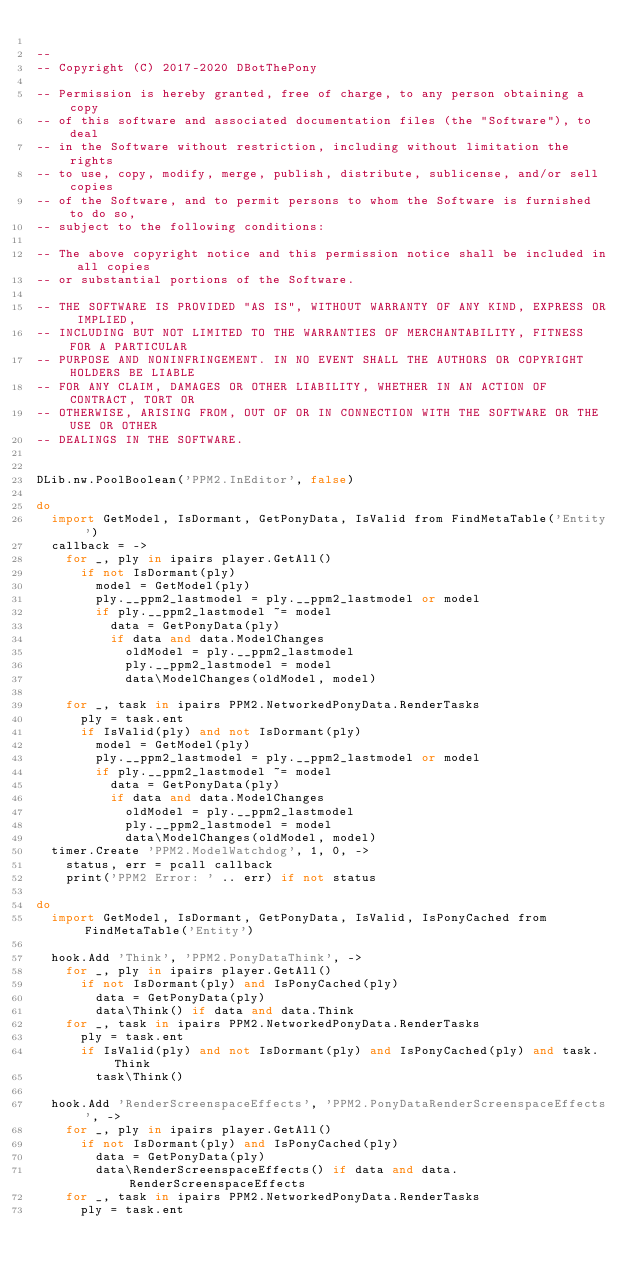<code> <loc_0><loc_0><loc_500><loc_500><_MoonScript_>
--
-- Copyright (C) 2017-2020 DBotThePony

-- Permission is hereby granted, free of charge, to any person obtaining a copy
-- of this software and associated documentation files (the "Software"), to deal
-- in the Software without restriction, including without limitation the rights
-- to use, copy, modify, merge, publish, distribute, sublicense, and/or sell copies
-- of the Software, and to permit persons to whom the Software is furnished to do so,
-- subject to the following conditions:

-- The above copyright notice and this permission notice shall be included in all copies
-- or substantial portions of the Software.

-- THE SOFTWARE IS PROVIDED "AS IS", WITHOUT WARRANTY OF ANY KIND, EXPRESS OR IMPLIED,
-- INCLUDING BUT NOT LIMITED TO THE WARRANTIES OF MERCHANTABILITY, FITNESS FOR A PARTICULAR
-- PURPOSE AND NONINFRINGEMENT. IN NO EVENT SHALL THE AUTHORS OR COPYRIGHT HOLDERS BE LIABLE
-- FOR ANY CLAIM, DAMAGES OR OTHER LIABILITY, WHETHER IN AN ACTION OF CONTRACT, TORT OR
-- OTHERWISE, ARISING FROM, OUT OF OR IN CONNECTION WITH THE SOFTWARE OR THE USE OR OTHER
-- DEALINGS IN THE SOFTWARE.


DLib.nw.PoolBoolean('PPM2.InEditor', false)

do
	import GetModel, IsDormant, GetPonyData, IsValid from FindMetaTable('Entity')
	callback = ->
		for _, ply in ipairs player.GetAll()
			if not IsDormant(ply)
				model = GetModel(ply)
				ply.__ppm2_lastmodel = ply.__ppm2_lastmodel or model
				if ply.__ppm2_lastmodel ~= model
					data = GetPonyData(ply)
					if data and data.ModelChanges
						oldModel = ply.__ppm2_lastmodel
						ply.__ppm2_lastmodel = model
						data\ModelChanges(oldModel, model)

		for _, task in ipairs PPM2.NetworkedPonyData.RenderTasks
			ply = task.ent
			if IsValid(ply) and not IsDormant(ply)
				model = GetModel(ply)
				ply.__ppm2_lastmodel = ply.__ppm2_lastmodel or model
				if ply.__ppm2_lastmodel ~= model
					data = GetPonyData(ply)
					if data and data.ModelChanges
						oldModel = ply.__ppm2_lastmodel
						ply.__ppm2_lastmodel = model
						data\ModelChanges(oldModel, model)
	timer.Create 'PPM2.ModelWatchdog', 1, 0, ->
		status, err = pcall callback
		print('PPM2 Error: ' .. err) if not status

do
	import GetModel, IsDormant, GetPonyData, IsValid, IsPonyCached from FindMetaTable('Entity')

	hook.Add 'Think', 'PPM2.PonyDataThink', ->
		for _, ply in ipairs player.GetAll()
			if not IsDormant(ply) and IsPonyCached(ply)
				data = GetPonyData(ply)
				data\Think() if data and data.Think
		for _, task in ipairs PPM2.NetworkedPonyData.RenderTasks
			ply = task.ent
			if IsValid(ply) and not IsDormant(ply) and IsPonyCached(ply) and task.Think
				task\Think()

	hook.Add 'RenderScreenspaceEffects', 'PPM2.PonyDataRenderScreenspaceEffects', ->
		for _, ply in ipairs player.GetAll()
			if not IsDormant(ply) and IsPonyCached(ply)
				data = GetPonyData(ply)
				data\RenderScreenspaceEffects() if data and data.RenderScreenspaceEffects
		for _, task in ipairs PPM2.NetworkedPonyData.RenderTasks
			ply = task.ent</code> 